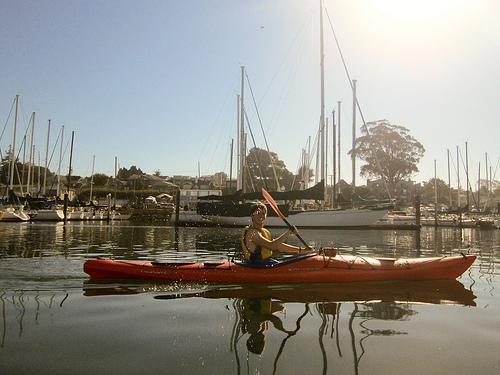How many people are shown?
Give a very brief answer. 1. 